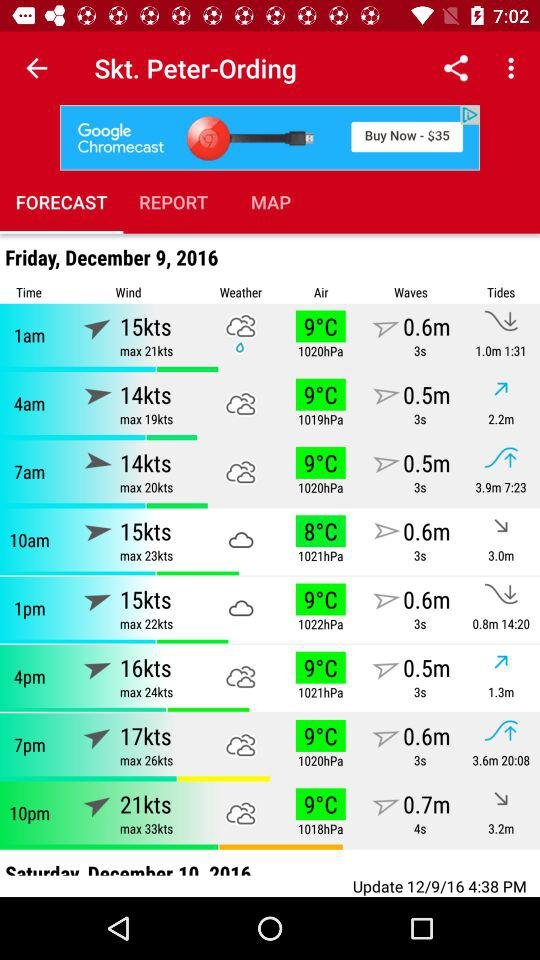Which tab is selected? The selected tab is "FORECAST". 